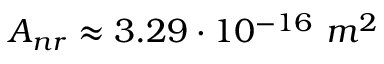Convert formula to latex. <formula><loc_0><loc_0><loc_500><loc_500>A _ { n r } \approx 3 . 2 9 \cdot 1 0 ^ { - 1 6 } \ m ^ { 2 }</formula> 